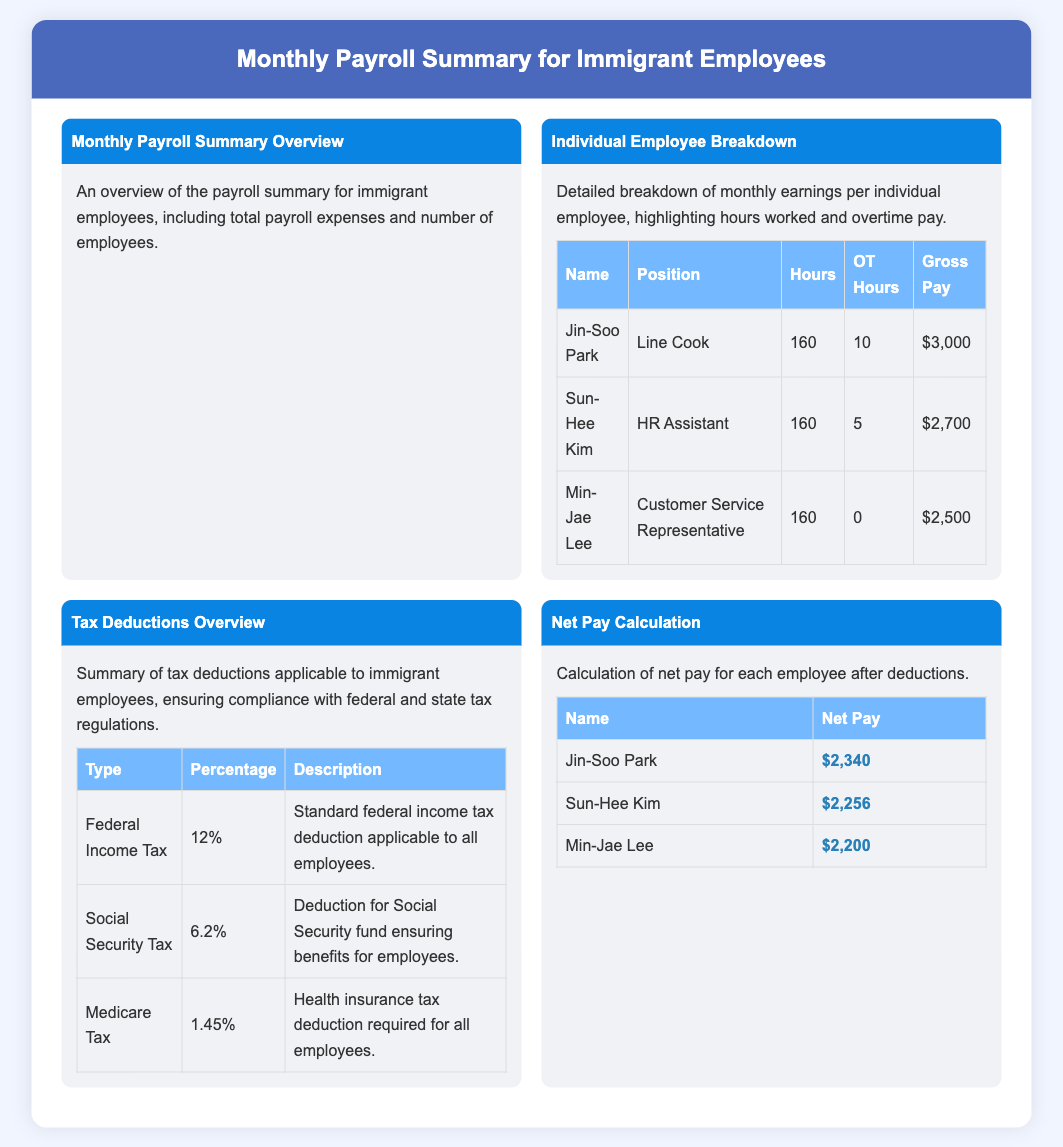What is the total gross pay for Jin-Soo Park? The gross pay for Jin-Soo Park is listed in the individual employee breakdown table, which is $3,000.
Answer: $3,000 How many hours did Sun-Hee Kim work? The hours worked by Sun-Hee Kim are shown in the individual employee breakdown table, which lists them as 160 hours.
Answer: 160 What is the federal income tax percentage? The tax deductions overview contains the federal income tax percentage, which is 12%.
Answer: 12% What is the net pay for Min-Jae Lee? The net pay for Min-Jae Lee is shown in the net pay calculation table, which states it is $2,200.
Answer: $2,200 How many employees are represented in the summary? The overview mentions the total number of employees, which can be derived from the individual breakdown; there are three employees listed.
Answer: 3 What position does Jin-Soo Park hold? Jin-Soo Park's position is specified in the individual employee breakdown table, listed as Line Cook.
Answer: Line Cook What type of tax has a 6.2% deduction? The tax deductions overview specifies that Social Security Tax has a 6.2% deduction.
Answer: Social Security Tax How many overtime hours did Min-Jae Lee have? The individual employee breakdown table shows that Min-Jae Lee had 0 overtime hours listed.
Answer: 0 What is the total number of menu items? The document presents four distinct menu items in the payroll summary.
Answer: 4 